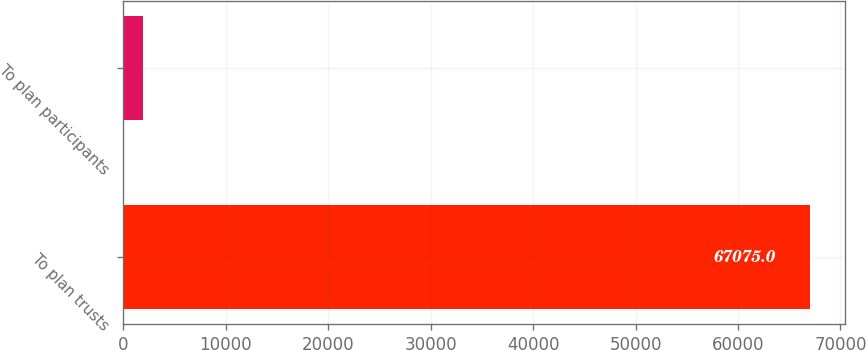<chart> <loc_0><loc_0><loc_500><loc_500><bar_chart><fcel>To plan trusts<fcel>To plan participants<nl><fcel>67075<fcel>1900<nl></chart> 